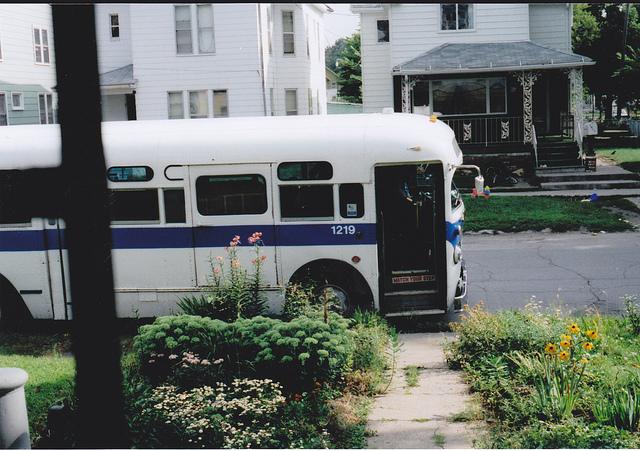How many vehicles are in the shot?
Short answer required. 1. Are they in the u.s.?
Answer briefly. Yes. Where is this?
Keep it brief. Town. What is the bus number?
Concise answer only. 1219. What color are the flowers?
Quick response, please. Yellow. Is this bus about to leave?
Quick response, please. Yes. Is this a city bus?
Keep it brief. Yes. What color is the bus?
Keep it brief. White. Is the bus equipped for handicapped passengers?
Answer briefly. Yes. What is the last number in the bus?
Be succinct. 9. 